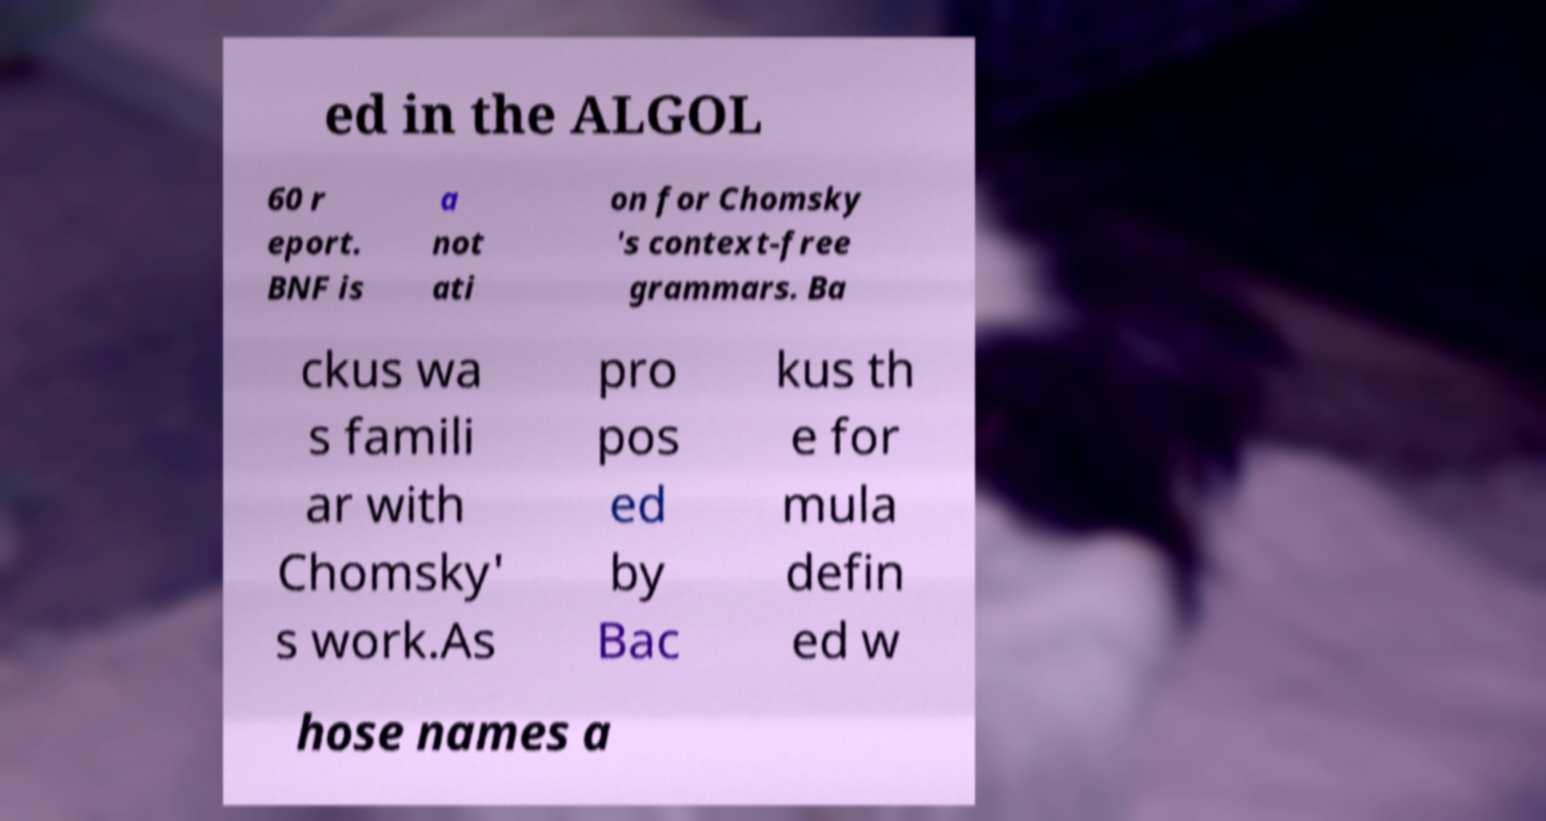Could you assist in decoding the text presented in this image and type it out clearly? ed in the ALGOL 60 r eport. BNF is a not ati on for Chomsky 's context-free grammars. Ba ckus wa s famili ar with Chomsky' s work.As pro pos ed by Bac kus th e for mula defin ed w hose names a 